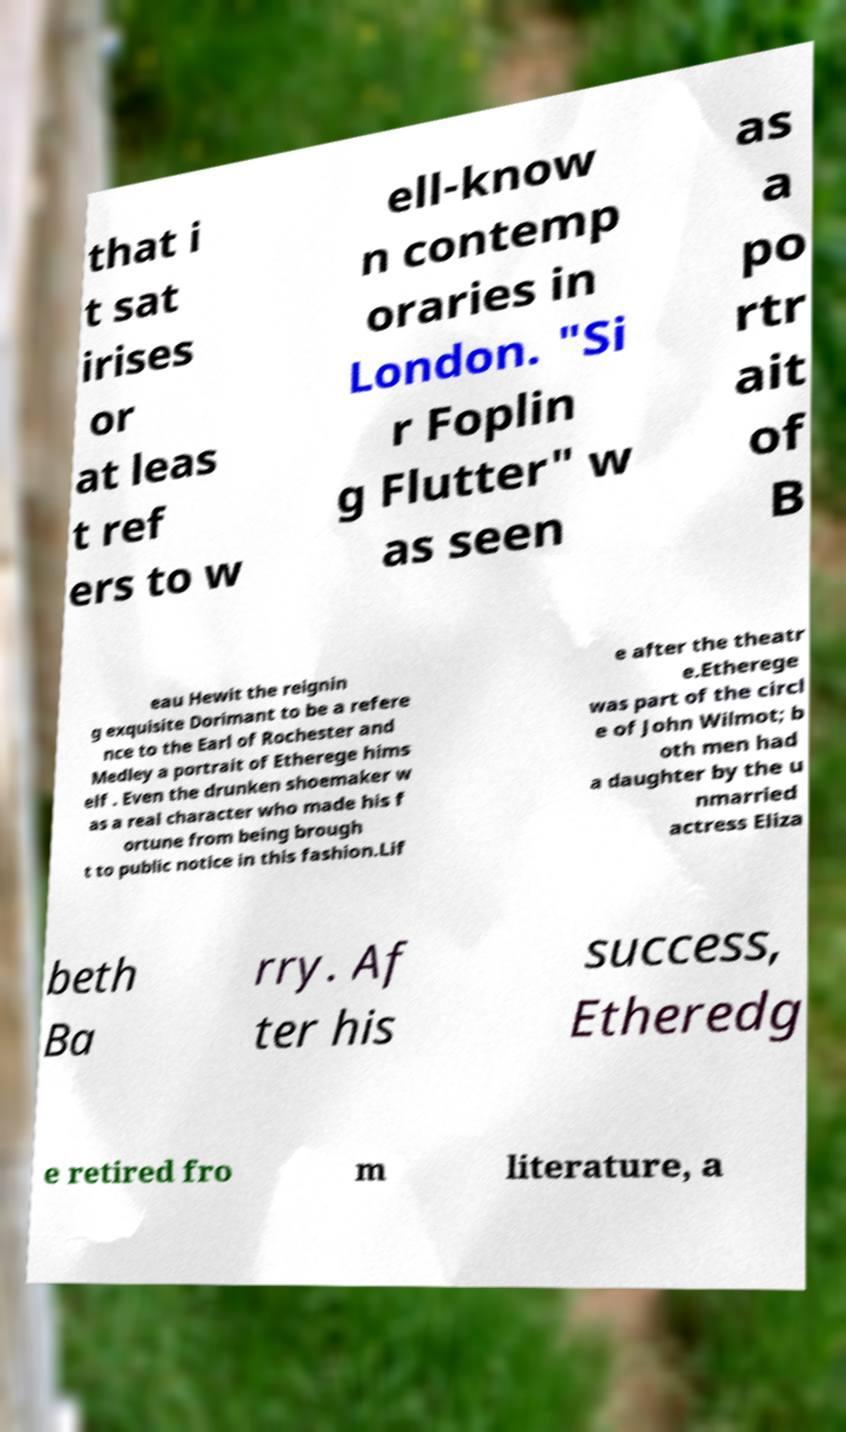Please identify and transcribe the text found in this image. that i t sat irises or at leas t ref ers to w ell-know n contemp oraries in London. "Si r Foplin g Flutter" w as seen as a po rtr ait of B eau Hewit the reignin g exquisite Dorimant to be a refere nce to the Earl of Rochester and Medley a portrait of Etherege hims elf . Even the drunken shoemaker w as a real character who made his f ortune from being brough t to public notice in this fashion.Lif e after the theatr e.Etherege was part of the circl e of John Wilmot; b oth men had a daughter by the u nmarried actress Eliza beth Ba rry. Af ter his success, Etheredg e retired fro m literature, a 